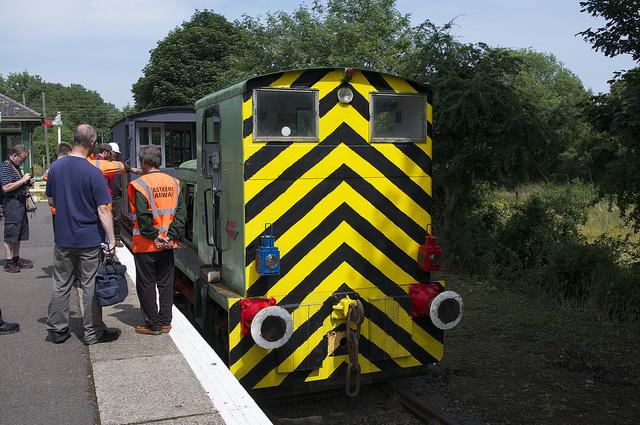Is the train currently in motion?
Concise answer only. No. What color is the front of the train?
Be succinct. Yellow and black. What color is the safety vest?
Concise answer only. Orange. 